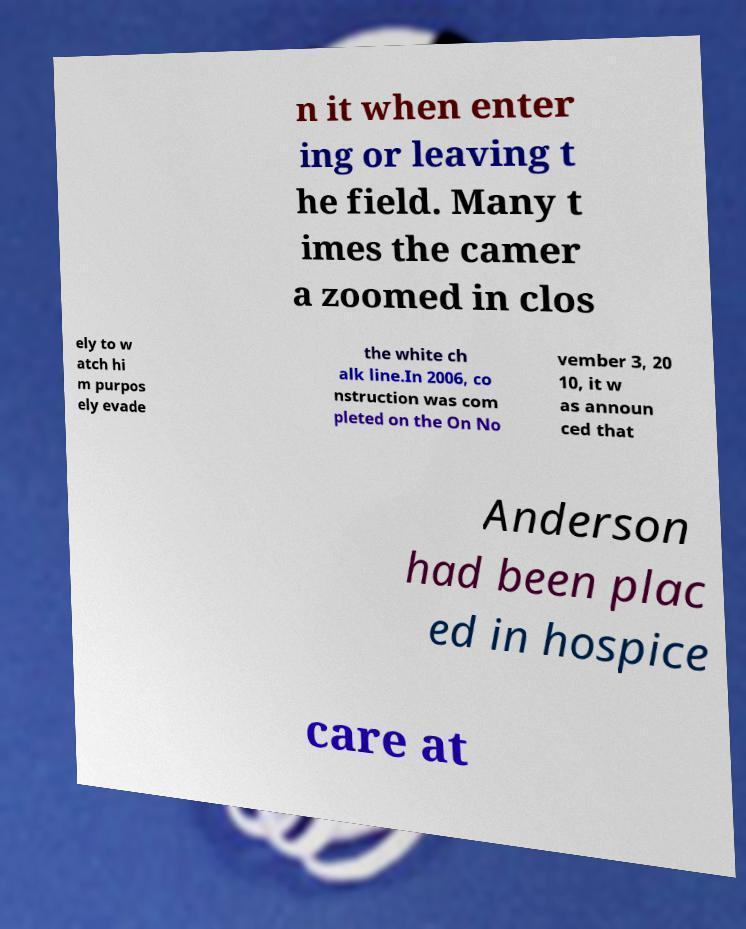Can you accurately transcribe the text from the provided image for me? n it when enter ing or leaving t he field. Many t imes the camer a zoomed in clos ely to w atch hi m purpos ely evade the white ch alk line.In 2006, co nstruction was com pleted on the On No vember 3, 20 10, it w as announ ced that Anderson had been plac ed in hospice care at 